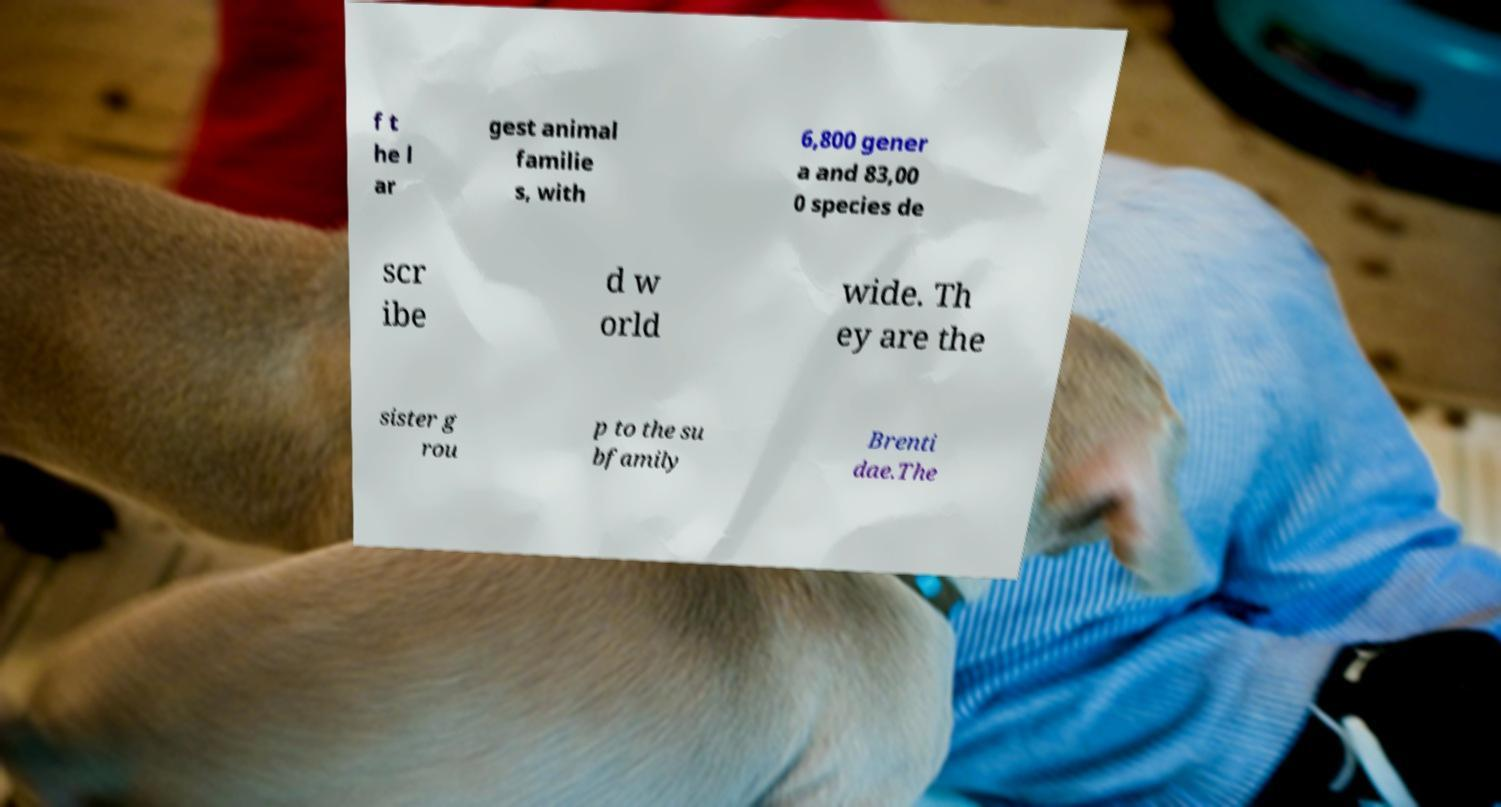Could you extract and type out the text from this image? f t he l ar gest animal familie s, with 6,800 gener a and 83,00 0 species de scr ibe d w orld wide. Th ey are the sister g rou p to the su bfamily Brenti dae.The 